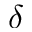Convert formula to latex. <formula><loc_0><loc_0><loc_500><loc_500>\delta</formula> 